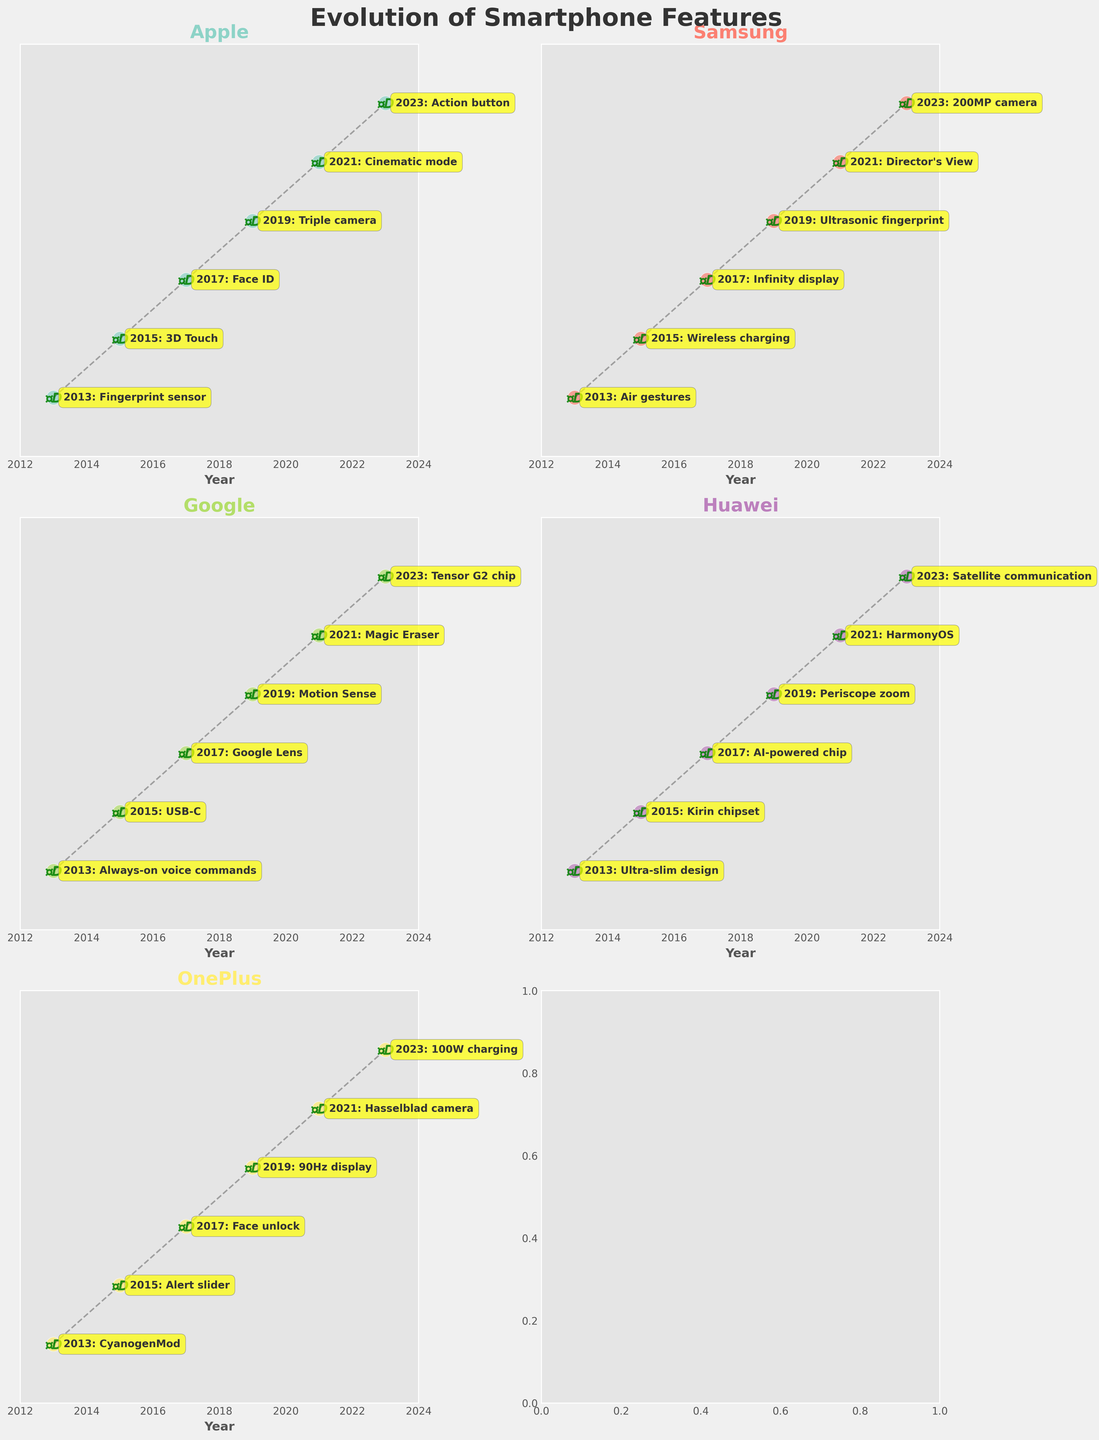How often do the subplots have alien spaceship icons? Every subplot includes alien spaceship icons seen along the dashed line connecting the years with data points.
Answer: All subplots Which brand introduced the feature 'Face ID' and in which year? The subplot for Apple shows that 'Face ID' was introduced with the iPhone X in the year 2017.
Answer: Apple, 2017 How many years are covered in the figure? The x-axis across the subplots ranges from the year 2013 to 2023, which is a span of 11 years.
Answer: 11 years How does the feature evolution trend differ for Google and Huawei? For Google, features focus on AI and software improvements like 'Google Lens' and 'Magic Eraser', while Huawei emphasized hardware and system innovations like 'Kirin chipset' and 'HarmonyOS'.
Answer: Software vs Hardware/System Which brand had the most significant camera upgrade in 2023? The Samsung subplot shows the introduction of a '200MP camera' in 2023, which is a considerable upgrade.
Answer: Samsung Compare the features introduced by Apple and OnePlus in 2019. What were they? In 2019, Apple introduced the 'Triple camera' in the iPhone 11 Pro, while OnePlus introduced a '90Hz display' in the OnePlus 7 Pro.
Answer: Triple camera (Apple) vs 90Hz display (OnePlus) What is the common trend observed in the features introduced by brands in 2021? In 2021, all brands introduced unique features enhancing user experience, like 'Cinematic mode' (Apple) and 'Magic Eraser' (Google), focusing on improving specific aspects of the smartphone.
Answer: User experience enhancements Which brand adopted new charging technology in one of the years, and what was it? In 2023, OnePlus introduced '100W charging' with the OnePlus 11.
Answer: OnePlus, 100W charging In which plot can you find the feature 'Periscope zoom'? The 'Periscope zoom' feature is shown in the subplot for Huawei, specifically for the year 2019 with the P30 Pro.
Answer: Huawei 